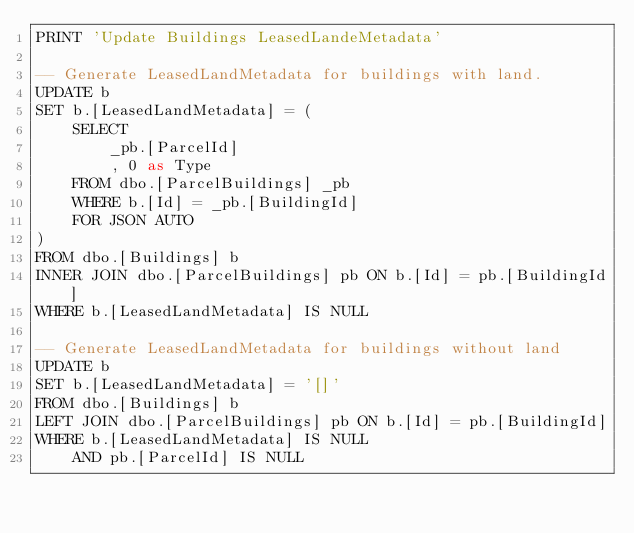Convert code to text. <code><loc_0><loc_0><loc_500><loc_500><_SQL_>PRINT 'Update Buildings LeasedLandeMetadata'

-- Generate LeasedLandMetadata for buildings with land.
UPDATE b
SET b.[LeasedLandMetadata] = (
    SELECT
        _pb.[ParcelId]
        , 0 as Type
    FROM dbo.[ParcelBuildings] _pb
    WHERE b.[Id] = _pb.[BuildingId]
    FOR JSON AUTO
)
FROM dbo.[Buildings] b
INNER JOIN dbo.[ParcelBuildings] pb ON b.[Id] = pb.[BuildingId]
WHERE b.[LeasedLandMetadata] IS NULL

-- Generate LeasedLandMetadata for buildings without land
UPDATE b
SET b.[LeasedLandMetadata] = '[]'
FROM dbo.[Buildings] b
LEFT JOIN dbo.[ParcelBuildings] pb ON b.[Id] = pb.[BuildingId]
WHERE b.[LeasedLandMetadata] IS NULL
    AND pb.[ParcelId] IS NULL
</code> 